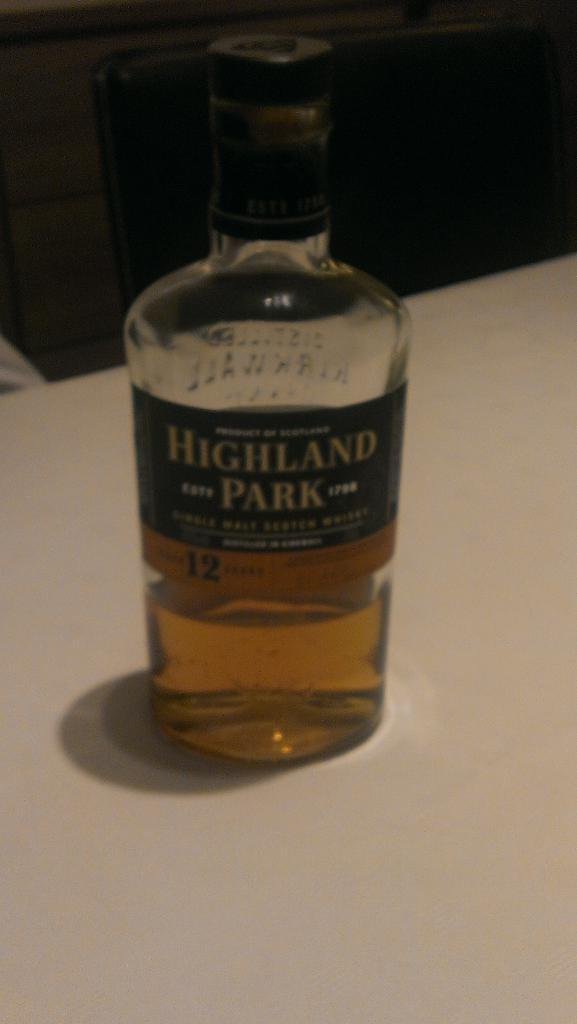Provide a one-sentence caption for the provided image. Tall clear bottle labeled Highland Park is sitting on the white surface. 